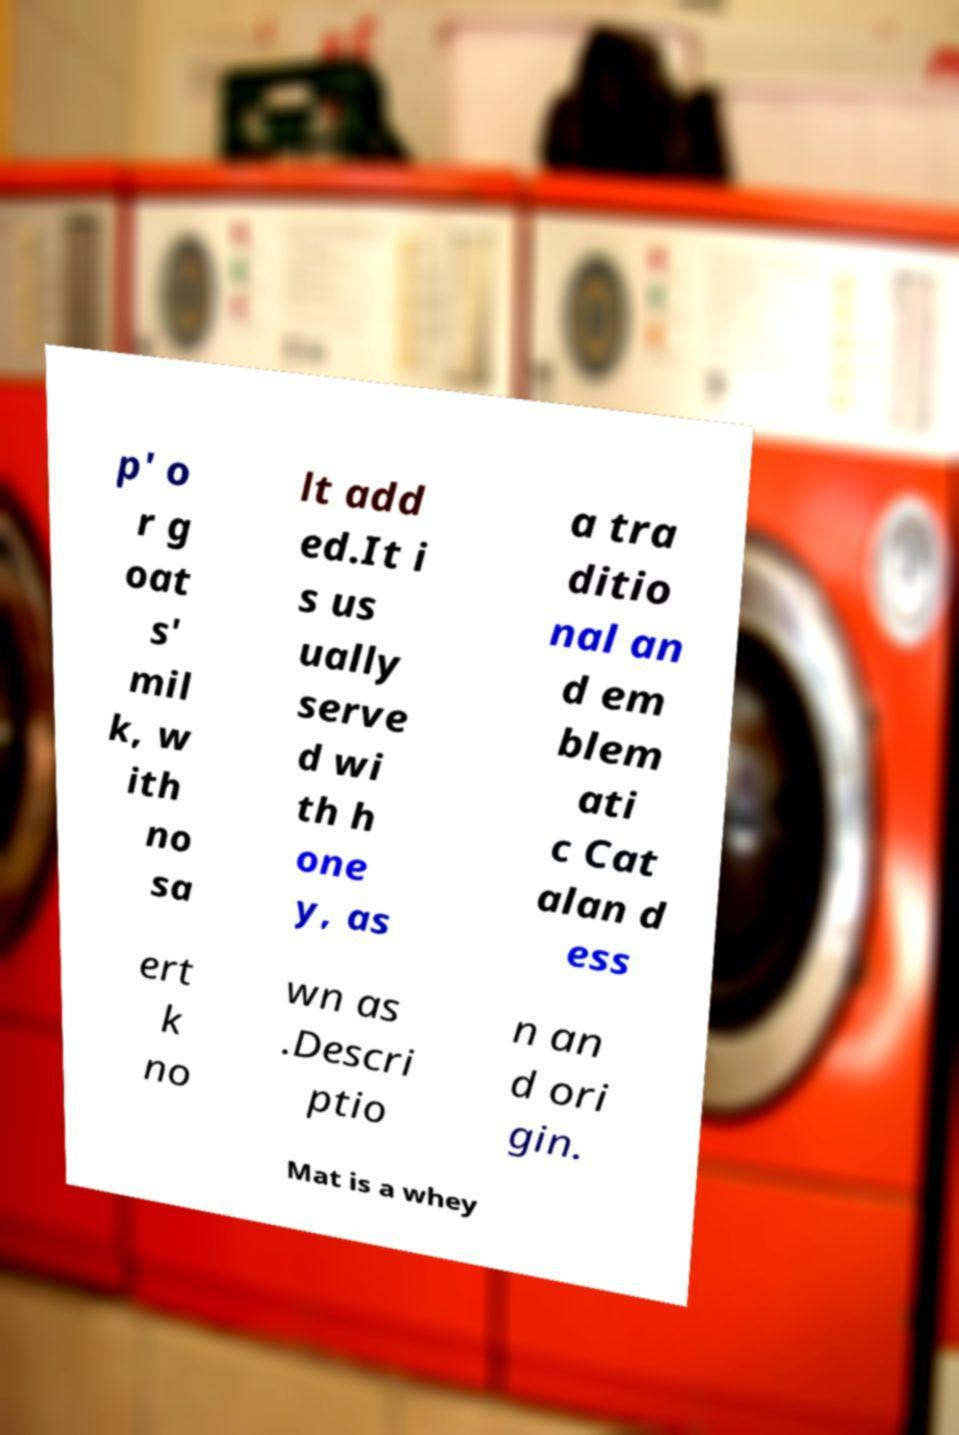Could you extract and type out the text from this image? p' o r g oat s' mil k, w ith no sa lt add ed.It i s us ually serve d wi th h one y, as a tra ditio nal an d em blem ati c Cat alan d ess ert k no wn as .Descri ptio n an d ori gin. Mat is a whey 